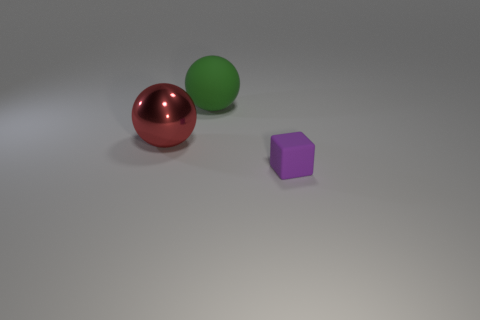Is the number of spheres that are on the right side of the red metallic ball greater than the number of tiny rubber objects?
Your response must be concise. No. There is a large ball left of the rubber object behind the small purple matte cube; how many matte objects are in front of it?
Give a very brief answer. 1. There is a rubber object that is behind the small purple matte cube; is its shape the same as the metallic object?
Keep it short and to the point. Yes. What is the big object behind the red metallic sphere made of?
Give a very brief answer. Rubber. What shape is the object that is to the right of the large shiny sphere and in front of the green matte ball?
Offer a very short reply. Cube. What is the material of the cube?
Offer a very short reply. Rubber. What number of cylinders are either tiny cyan shiny things or large green things?
Offer a very short reply. 0. Is the red sphere made of the same material as the green ball?
Ensure brevity in your answer.  No. What size is the green matte object that is the same shape as the red metal object?
Give a very brief answer. Large. The object that is both behind the small object and in front of the large green sphere is made of what material?
Keep it short and to the point. Metal. 